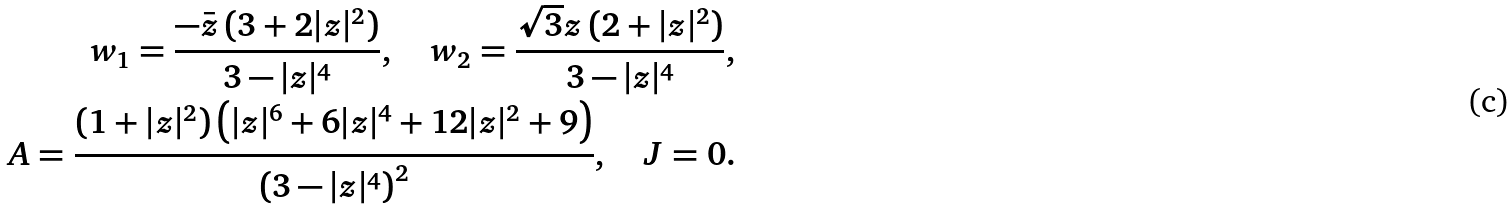<formula> <loc_0><loc_0><loc_500><loc_500>w _ { 1 } = \frac { - \bar { z } \left ( 3 + 2 | z | ^ { 2 } \right ) } { 3 - | z | ^ { 4 } } , \quad w _ { 2 } = \frac { \sqrt { 3 } z \left ( 2 + | z | ^ { 2 } \right ) } { 3 - | z | ^ { 4 } } , \\ A = \frac { \left ( 1 + | z | ^ { 2 } \right ) \left ( | z | ^ { 6 } + 6 | z | ^ { 4 } + 1 2 | z | ^ { 2 } + 9 \right ) } { \left ( 3 - | z | ^ { 4 } \right ) ^ { 2 } } , \quad J = 0 .</formula> 